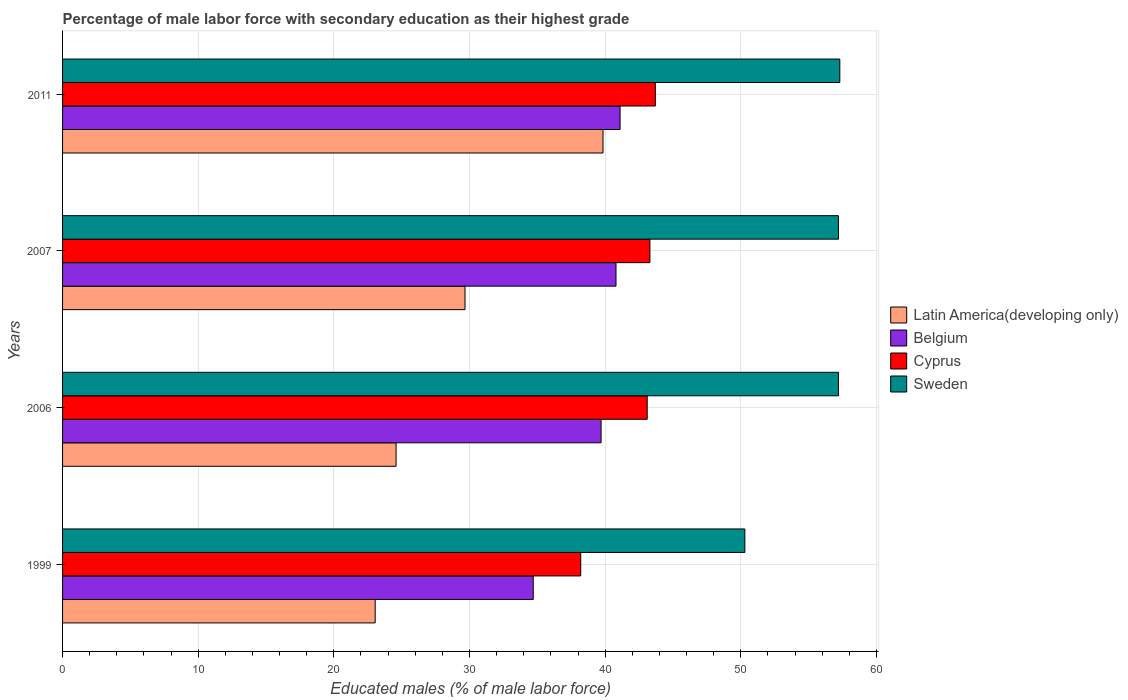How many different coloured bars are there?
Your response must be concise. 4. Are the number of bars per tick equal to the number of legend labels?
Your response must be concise. Yes. How many bars are there on the 3rd tick from the bottom?
Give a very brief answer. 4. What is the label of the 1st group of bars from the top?
Give a very brief answer. 2011. In how many cases, is the number of bars for a given year not equal to the number of legend labels?
Provide a short and direct response. 0. What is the percentage of male labor force with secondary education in Sweden in 2007?
Your answer should be very brief. 57.2. Across all years, what is the maximum percentage of male labor force with secondary education in Latin America(developing only)?
Make the answer very short. 39.84. Across all years, what is the minimum percentage of male labor force with secondary education in Cyprus?
Give a very brief answer. 38.2. In which year was the percentage of male labor force with secondary education in Cyprus maximum?
Keep it short and to the point. 2011. What is the total percentage of male labor force with secondary education in Belgium in the graph?
Give a very brief answer. 156.3. What is the difference between the percentage of male labor force with secondary education in Cyprus in 2006 and that in 2011?
Make the answer very short. -0.6. What is the difference between the percentage of male labor force with secondary education in Latin America(developing only) in 2006 and the percentage of male labor force with secondary education in Belgium in 2011?
Provide a short and direct response. -16.51. What is the average percentage of male labor force with secondary education in Cyprus per year?
Provide a succinct answer. 42.07. In the year 2006, what is the difference between the percentage of male labor force with secondary education in Cyprus and percentage of male labor force with secondary education in Sweden?
Provide a short and direct response. -14.1. In how many years, is the percentage of male labor force with secondary education in Cyprus greater than 12 %?
Your answer should be very brief. 4. What is the ratio of the percentage of male labor force with secondary education in Cyprus in 1999 to that in 2007?
Your answer should be very brief. 0.88. What is the difference between the highest and the second highest percentage of male labor force with secondary education in Sweden?
Keep it short and to the point. 0.1. In how many years, is the percentage of male labor force with secondary education in Sweden greater than the average percentage of male labor force with secondary education in Sweden taken over all years?
Provide a short and direct response. 3. What does the 4th bar from the bottom in 1999 represents?
Make the answer very short. Sweden. Is it the case that in every year, the sum of the percentage of male labor force with secondary education in Latin America(developing only) and percentage of male labor force with secondary education in Belgium is greater than the percentage of male labor force with secondary education in Cyprus?
Your response must be concise. Yes. How many bars are there?
Offer a very short reply. 16. Are all the bars in the graph horizontal?
Offer a terse response. Yes. Are the values on the major ticks of X-axis written in scientific E-notation?
Give a very brief answer. No. Does the graph contain grids?
Your answer should be very brief. Yes. Where does the legend appear in the graph?
Provide a succinct answer. Center right. How many legend labels are there?
Your answer should be very brief. 4. What is the title of the graph?
Offer a very short reply. Percentage of male labor force with secondary education as their highest grade. What is the label or title of the X-axis?
Your answer should be compact. Educated males (% of male labor force). What is the Educated males (% of male labor force) of Latin America(developing only) in 1999?
Offer a very short reply. 23.05. What is the Educated males (% of male labor force) of Belgium in 1999?
Offer a terse response. 34.7. What is the Educated males (% of male labor force) of Cyprus in 1999?
Provide a succinct answer. 38.2. What is the Educated males (% of male labor force) of Sweden in 1999?
Provide a succinct answer. 50.3. What is the Educated males (% of male labor force) in Latin America(developing only) in 2006?
Provide a succinct answer. 24.59. What is the Educated males (% of male labor force) of Belgium in 2006?
Offer a very short reply. 39.7. What is the Educated males (% of male labor force) of Cyprus in 2006?
Your response must be concise. 43.1. What is the Educated males (% of male labor force) in Sweden in 2006?
Offer a very short reply. 57.2. What is the Educated males (% of male labor force) of Latin America(developing only) in 2007?
Your response must be concise. 29.67. What is the Educated males (% of male labor force) in Belgium in 2007?
Give a very brief answer. 40.8. What is the Educated males (% of male labor force) in Cyprus in 2007?
Ensure brevity in your answer.  43.3. What is the Educated males (% of male labor force) of Sweden in 2007?
Make the answer very short. 57.2. What is the Educated males (% of male labor force) of Latin America(developing only) in 2011?
Offer a very short reply. 39.84. What is the Educated males (% of male labor force) of Belgium in 2011?
Offer a terse response. 41.1. What is the Educated males (% of male labor force) of Cyprus in 2011?
Your response must be concise. 43.7. What is the Educated males (% of male labor force) of Sweden in 2011?
Ensure brevity in your answer.  57.3. Across all years, what is the maximum Educated males (% of male labor force) in Latin America(developing only)?
Provide a short and direct response. 39.84. Across all years, what is the maximum Educated males (% of male labor force) of Belgium?
Offer a terse response. 41.1. Across all years, what is the maximum Educated males (% of male labor force) in Cyprus?
Ensure brevity in your answer.  43.7. Across all years, what is the maximum Educated males (% of male labor force) in Sweden?
Keep it short and to the point. 57.3. Across all years, what is the minimum Educated males (% of male labor force) in Latin America(developing only)?
Keep it short and to the point. 23.05. Across all years, what is the minimum Educated males (% of male labor force) in Belgium?
Provide a succinct answer. 34.7. Across all years, what is the minimum Educated males (% of male labor force) in Cyprus?
Ensure brevity in your answer.  38.2. Across all years, what is the minimum Educated males (% of male labor force) in Sweden?
Ensure brevity in your answer.  50.3. What is the total Educated males (% of male labor force) of Latin America(developing only) in the graph?
Your response must be concise. 117.15. What is the total Educated males (% of male labor force) of Belgium in the graph?
Your answer should be compact. 156.3. What is the total Educated males (% of male labor force) of Cyprus in the graph?
Ensure brevity in your answer.  168.3. What is the total Educated males (% of male labor force) of Sweden in the graph?
Ensure brevity in your answer.  222. What is the difference between the Educated males (% of male labor force) in Latin America(developing only) in 1999 and that in 2006?
Your answer should be compact. -1.54. What is the difference between the Educated males (% of male labor force) in Sweden in 1999 and that in 2006?
Your response must be concise. -6.9. What is the difference between the Educated males (% of male labor force) in Latin America(developing only) in 1999 and that in 2007?
Give a very brief answer. -6.62. What is the difference between the Educated males (% of male labor force) of Belgium in 1999 and that in 2007?
Provide a succinct answer. -6.1. What is the difference between the Educated males (% of male labor force) in Cyprus in 1999 and that in 2007?
Keep it short and to the point. -5.1. What is the difference between the Educated males (% of male labor force) in Sweden in 1999 and that in 2007?
Ensure brevity in your answer.  -6.9. What is the difference between the Educated males (% of male labor force) of Latin America(developing only) in 1999 and that in 2011?
Your response must be concise. -16.8. What is the difference between the Educated males (% of male labor force) in Belgium in 1999 and that in 2011?
Provide a short and direct response. -6.4. What is the difference between the Educated males (% of male labor force) of Cyprus in 1999 and that in 2011?
Keep it short and to the point. -5.5. What is the difference between the Educated males (% of male labor force) of Latin America(developing only) in 2006 and that in 2007?
Provide a short and direct response. -5.08. What is the difference between the Educated males (% of male labor force) of Belgium in 2006 and that in 2007?
Ensure brevity in your answer.  -1.1. What is the difference between the Educated males (% of male labor force) of Cyprus in 2006 and that in 2007?
Offer a very short reply. -0.2. What is the difference between the Educated males (% of male labor force) in Sweden in 2006 and that in 2007?
Provide a succinct answer. 0. What is the difference between the Educated males (% of male labor force) of Latin America(developing only) in 2006 and that in 2011?
Offer a very short reply. -15.25. What is the difference between the Educated males (% of male labor force) in Belgium in 2006 and that in 2011?
Give a very brief answer. -1.4. What is the difference between the Educated males (% of male labor force) in Cyprus in 2006 and that in 2011?
Provide a succinct answer. -0.6. What is the difference between the Educated males (% of male labor force) of Latin America(developing only) in 2007 and that in 2011?
Provide a succinct answer. -10.17. What is the difference between the Educated males (% of male labor force) of Belgium in 2007 and that in 2011?
Provide a succinct answer. -0.3. What is the difference between the Educated males (% of male labor force) in Latin America(developing only) in 1999 and the Educated males (% of male labor force) in Belgium in 2006?
Provide a succinct answer. -16.65. What is the difference between the Educated males (% of male labor force) of Latin America(developing only) in 1999 and the Educated males (% of male labor force) of Cyprus in 2006?
Give a very brief answer. -20.05. What is the difference between the Educated males (% of male labor force) of Latin America(developing only) in 1999 and the Educated males (% of male labor force) of Sweden in 2006?
Give a very brief answer. -34.15. What is the difference between the Educated males (% of male labor force) of Belgium in 1999 and the Educated males (% of male labor force) of Cyprus in 2006?
Your answer should be very brief. -8.4. What is the difference between the Educated males (% of male labor force) of Belgium in 1999 and the Educated males (% of male labor force) of Sweden in 2006?
Give a very brief answer. -22.5. What is the difference between the Educated males (% of male labor force) in Cyprus in 1999 and the Educated males (% of male labor force) in Sweden in 2006?
Keep it short and to the point. -19. What is the difference between the Educated males (% of male labor force) in Latin America(developing only) in 1999 and the Educated males (% of male labor force) in Belgium in 2007?
Make the answer very short. -17.75. What is the difference between the Educated males (% of male labor force) of Latin America(developing only) in 1999 and the Educated males (% of male labor force) of Cyprus in 2007?
Provide a succinct answer. -20.25. What is the difference between the Educated males (% of male labor force) of Latin America(developing only) in 1999 and the Educated males (% of male labor force) of Sweden in 2007?
Make the answer very short. -34.15. What is the difference between the Educated males (% of male labor force) of Belgium in 1999 and the Educated males (% of male labor force) of Sweden in 2007?
Ensure brevity in your answer.  -22.5. What is the difference between the Educated males (% of male labor force) in Latin America(developing only) in 1999 and the Educated males (% of male labor force) in Belgium in 2011?
Provide a succinct answer. -18.05. What is the difference between the Educated males (% of male labor force) in Latin America(developing only) in 1999 and the Educated males (% of male labor force) in Cyprus in 2011?
Your answer should be compact. -20.65. What is the difference between the Educated males (% of male labor force) in Latin America(developing only) in 1999 and the Educated males (% of male labor force) in Sweden in 2011?
Your response must be concise. -34.25. What is the difference between the Educated males (% of male labor force) in Belgium in 1999 and the Educated males (% of male labor force) in Cyprus in 2011?
Ensure brevity in your answer.  -9. What is the difference between the Educated males (% of male labor force) in Belgium in 1999 and the Educated males (% of male labor force) in Sweden in 2011?
Your answer should be very brief. -22.6. What is the difference between the Educated males (% of male labor force) of Cyprus in 1999 and the Educated males (% of male labor force) of Sweden in 2011?
Make the answer very short. -19.1. What is the difference between the Educated males (% of male labor force) in Latin America(developing only) in 2006 and the Educated males (% of male labor force) in Belgium in 2007?
Ensure brevity in your answer.  -16.21. What is the difference between the Educated males (% of male labor force) of Latin America(developing only) in 2006 and the Educated males (% of male labor force) of Cyprus in 2007?
Your response must be concise. -18.71. What is the difference between the Educated males (% of male labor force) in Latin America(developing only) in 2006 and the Educated males (% of male labor force) in Sweden in 2007?
Your response must be concise. -32.61. What is the difference between the Educated males (% of male labor force) in Belgium in 2006 and the Educated males (% of male labor force) in Cyprus in 2007?
Your answer should be very brief. -3.6. What is the difference between the Educated males (% of male labor force) in Belgium in 2006 and the Educated males (% of male labor force) in Sweden in 2007?
Your answer should be very brief. -17.5. What is the difference between the Educated males (% of male labor force) in Cyprus in 2006 and the Educated males (% of male labor force) in Sweden in 2007?
Your response must be concise. -14.1. What is the difference between the Educated males (% of male labor force) of Latin America(developing only) in 2006 and the Educated males (% of male labor force) of Belgium in 2011?
Ensure brevity in your answer.  -16.51. What is the difference between the Educated males (% of male labor force) of Latin America(developing only) in 2006 and the Educated males (% of male labor force) of Cyprus in 2011?
Give a very brief answer. -19.11. What is the difference between the Educated males (% of male labor force) in Latin America(developing only) in 2006 and the Educated males (% of male labor force) in Sweden in 2011?
Keep it short and to the point. -32.71. What is the difference between the Educated males (% of male labor force) in Belgium in 2006 and the Educated males (% of male labor force) in Sweden in 2011?
Your answer should be compact. -17.6. What is the difference between the Educated males (% of male labor force) in Cyprus in 2006 and the Educated males (% of male labor force) in Sweden in 2011?
Offer a terse response. -14.2. What is the difference between the Educated males (% of male labor force) in Latin America(developing only) in 2007 and the Educated males (% of male labor force) in Belgium in 2011?
Offer a very short reply. -11.43. What is the difference between the Educated males (% of male labor force) in Latin America(developing only) in 2007 and the Educated males (% of male labor force) in Cyprus in 2011?
Your answer should be compact. -14.03. What is the difference between the Educated males (% of male labor force) in Latin America(developing only) in 2007 and the Educated males (% of male labor force) in Sweden in 2011?
Give a very brief answer. -27.63. What is the difference between the Educated males (% of male labor force) in Belgium in 2007 and the Educated males (% of male labor force) in Sweden in 2011?
Your answer should be compact. -16.5. What is the average Educated males (% of male labor force) of Latin America(developing only) per year?
Your response must be concise. 29.29. What is the average Educated males (% of male labor force) in Belgium per year?
Make the answer very short. 39.08. What is the average Educated males (% of male labor force) in Cyprus per year?
Provide a succinct answer. 42.08. What is the average Educated males (% of male labor force) of Sweden per year?
Give a very brief answer. 55.5. In the year 1999, what is the difference between the Educated males (% of male labor force) in Latin America(developing only) and Educated males (% of male labor force) in Belgium?
Your answer should be very brief. -11.65. In the year 1999, what is the difference between the Educated males (% of male labor force) in Latin America(developing only) and Educated males (% of male labor force) in Cyprus?
Offer a terse response. -15.15. In the year 1999, what is the difference between the Educated males (% of male labor force) of Latin America(developing only) and Educated males (% of male labor force) of Sweden?
Offer a terse response. -27.25. In the year 1999, what is the difference between the Educated males (% of male labor force) of Belgium and Educated males (% of male labor force) of Cyprus?
Offer a terse response. -3.5. In the year 1999, what is the difference between the Educated males (% of male labor force) of Belgium and Educated males (% of male labor force) of Sweden?
Offer a very short reply. -15.6. In the year 1999, what is the difference between the Educated males (% of male labor force) of Cyprus and Educated males (% of male labor force) of Sweden?
Keep it short and to the point. -12.1. In the year 2006, what is the difference between the Educated males (% of male labor force) in Latin America(developing only) and Educated males (% of male labor force) in Belgium?
Provide a succinct answer. -15.11. In the year 2006, what is the difference between the Educated males (% of male labor force) of Latin America(developing only) and Educated males (% of male labor force) of Cyprus?
Offer a terse response. -18.51. In the year 2006, what is the difference between the Educated males (% of male labor force) of Latin America(developing only) and Educated males (% of male labor force) of Sweden?
Provide a short and direct response. -32.61. In the year 2006, what is the difference between the Educated males (% of male labor force) in Belgium and Educated males (% of male labor force) in Cyprus?
Give a very brief answer. -3.4. In the year 2006, what is the difference between the Educated males (% of male labor force) of Belgium and Educated males (% of male labor force) of Sweden?
Keep it short and to the point. -17.5. In the year 2006, what is the difference between the Educated males (% of male labor force) of Cyprus and Educated males (% of male labor force) of Sweden?
Provide a short and direct response. -14.1. In the year 2007, what is the difference between the Educated males (% of male labor force) of Latin America(developing only) and Educated males (% of male labor force) of Belgium?
Your response must be concise. -11.13. In the year 2007, what is the difference between the Educated males (% of male labor force) in Latin America(developing only) and Educated males (% of male labor force) in Cyprus?
Make the answer very short. -13.63. In the year 2007, what is the difference between the Educated males (% of male labor force) in Latin America(developing only) and Educated males (% of male labor force) in Sweden?
Offer a terse response. -27.53. In the year 2007, what is the difference between the Educated males (% of male labor force) of Belgium and Educated males (% of male labor force) of Cyprus?
Give a very brief answer. -2.5. In the year 2007, what is the difference between the Educated males (% of male labor force) in Belgium and Educated males (% of male labor force) in Sweden?
Your answer should be very brief. -16.4. In the year 2011, what is the difference between the Educated males (% of male labor force) of Latin America(developing only) and Educated males (% of male labor force) of Belgium?
Your answer should be very brief. -1.26. In the year 2011, what is the difference between the Educated males (% of male labor force) of Latin America(developing only) and Educated males (% of male labor force) of Cyprus?
Your response must be concise. -3.86. In the year 2011, what is the difference between the Educated males (% of male labor force) in Latin America(developing only) and Educated males (% of male labor force) in Sweden?
Keep it short and to the point. -17.46. In the year 2011, what is the difference between the Educated males (% of male labor force) in Belgium and Educated males (% of male labor force) in Sweden?
Offer a very short reply. -16.2. What is the ratio of the Educated males (% of male labor force) in Latin America(developing only) in 1999 to that in 2006?
Provide a short and direct response. 0.94. What is the ratio of the Educated males (% of male labor force) of Belgium in 1999 to that in 2006?
Make the answer very short. 0.87. What is the ratio of the Educated males (% of male labor force) in Cyprus in 1999 to that in 2006?
Provide a short and direct response. 0.89. What is the ratio of the Educated males (% of male labor force) in Sweden in 1999 to that in 2006?
Your response must be concise. 0.88. What is the ratio of the Educated males (% of male labor force) in Latin America(developing only) in 1999 to that in 2007?
Ensure brevity in your answer.  0.78. What is the ratio of the Educated males (% of male labor force) in Belgium in 1999 to that in 2007?
Offer a very short reply. 0.85. What is the ratio of the Educated males (% of male labor force) in Cyprus in 1999 to that in 2007?
Offer a terse response. 0.88. What is the ratio of the Educated males (% of male labor force) in Sweden in 1999 to that in 2007?
Make the answer very short. 0.88. What is the ratio of the Educated males (% of male labor force) in Latin America(developing only) in 1999 to that in 2011?
Keep it short and to the point. 0.58. What is the ratio of the Educated males (% of male labor force) of Belgium in 1999 to that in 2011?
Offer a very short reply. 0.84. What is the ratio of the Educated males (% of male labor force) of Cyprus in 1999 to that in 2011?
Make the answer very short. 0.87. What is the ratio of the Educated males (% of male labor force) in Sweden in 1999 to that in 2011?
Keep it short and to the point. 0.88. What is the ratio of the Educated males (% of male labor force) of Latin America(developing only) in 2006 to that in 2007?
Provide a succinct answer. 0.83. What is the ratio of the Educated males (% of male labor force) in Belgium in 2006 to that in 2007?
Provide a succinct answer. 0.97. What is the ratio of the Educated males (% of male labor force) of Cyprus in 2006 to that in 2007?
Give a very brief answer. 1. What is the ratio of the Educated males (% of male labor force) of Sweden in 2006 to that in 2007?
Your answer should be compact. 1. What is the ratio of the Educated males (% of male labor force) of Latin America(developing only) in 2006 to that in 2011?
Your response must be concise. 0.62. What is the ratio of the Educated males (% of male labor force) of Belgium in 2006 to that in 2011?
Ensure brevity in your answer.  0.97. What is the ratio of the Educated males (% of male labor force) of Cyprus in 2006 to that in 2011?
Ensure brevity in your answer.  0.99. What is the ratio of the Educated males (% of male labor force) in Sweden in 2006 to that in 2011?
Give a very brief answer. 1. What is the ratio of the Educated males (% of male labor force) of Latin America(developing only) in 2007 to that in 2011?
Give a very brief answer. 0.74. What is the difference between the highest and the second highest Educated males (% of male labor force) of Latin America(developing only)?
Offer a very short reply. 10.17. What is the difference between the highest and the second highest Educated males (% of male labor force) in Belgium?
Provide a short and direct response. 0.3. What is the difference between the highest and the lowest Educated males (% of male labor force) in Latin America(developing only)?
Provide a succinct answer. 16.8. What is the difference between the highest and the lowest Educated males (% of male labor force) of Cyprus?
Your response must be concise. 5.5. 